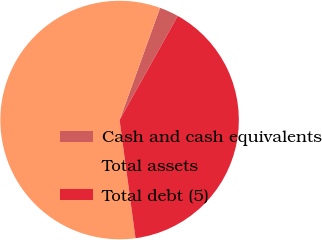<chart> <loc_0><loc_0><loc_500><loc_500><pie_chart><fcel>Cash and cash equivalents<fcel>Total assets<fcel>Total debt (5)<nl><fcel>2.6%<fcel>57.64%<fcel>39.76%<nl></chart> 